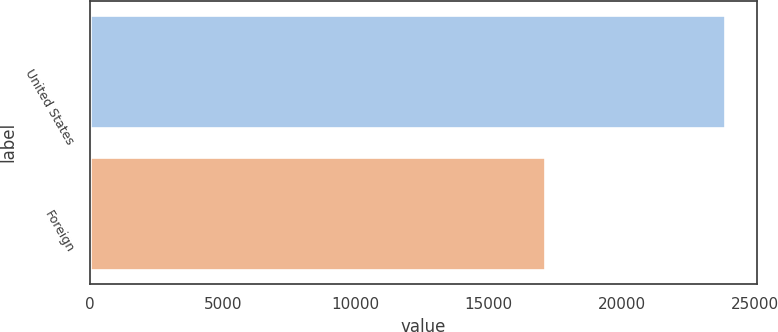Convert chart to OTSL. <chart><loc_0><loc_0><loc_500><loc_500><bar_chart><fcel>United States<fcel>Foreign<nl><fcel>23885<fcel>17104<nl></chart> 